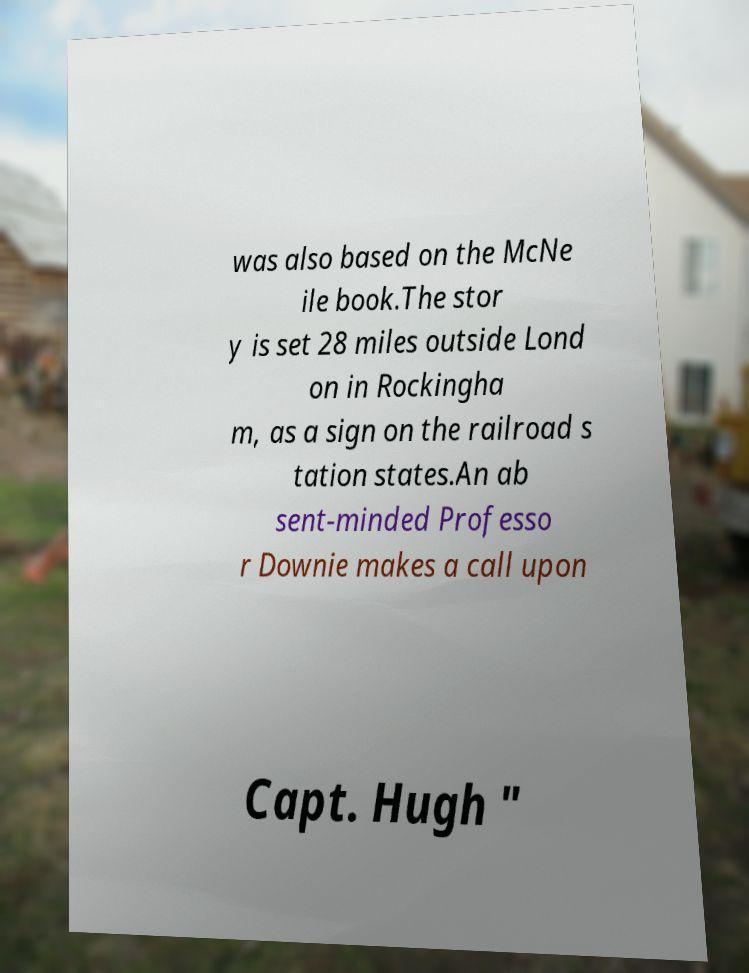Please identify and transcribe the text found in this image. was also based on the McNe ile book.The stor y is set 28 miles outside Lond on in Rockingha m, as a sign on the railroad s tation states.An ab sent-minded Professo r Downie makes a call upon Capt. Hugh " 